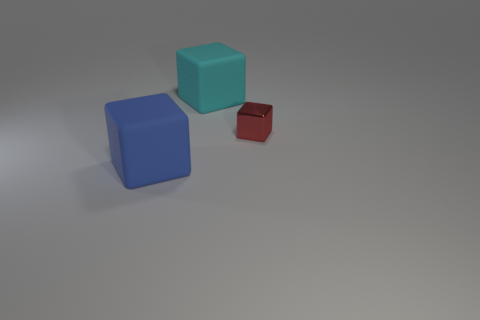Subtract all cyan rubber cubes. How many cubes are left? 2 Add 3 small green metal cubes. How many objects exist? 6 Subtract all yellow cubes. Subtract all green cylinders. How many cubes are left? 3 Subtract all tiny green matte objects. Subtract all blocks. How many objects are left? 0 Add 1 big cyan objects. How many big cyan objects are left? 2 Add 1 large blue objects. How many large blue objects exist? 2 Subtract 0 cyan cylinders. How many objects are left? 3 